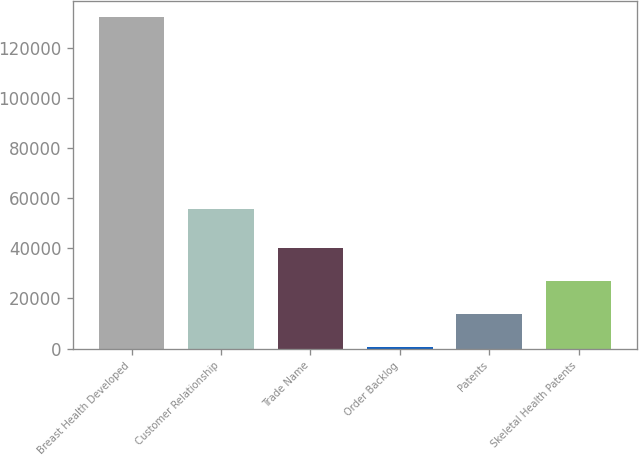Convert chart. <chart><loc_0><loc_0><loc_500><loc_500><bar_chart><fcel>Breast Health Developed<fcel>Customer Relationship<fcel>Trade Name<fcel>Order Backlog<fcel>Patents<fcel>Skeletal Health Patents<nl><fcel>132257<fcel>55692<fcel>40237.1<fcel>800<fcel>13945.7<fcel>27091.4<nl></chart> 